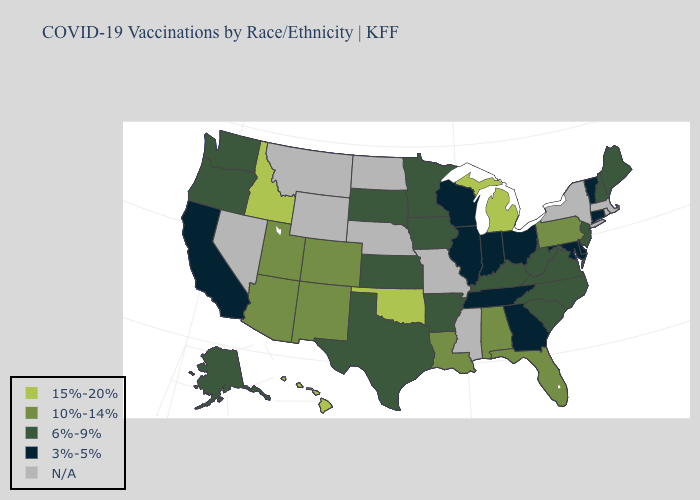What is the value of West Virginia?
Quick response, please. 6%-9%. What is the highest value in the MidWest ?
Be succinct. 15%-20%. Does Oklahoma have the highest value in the South?
Answer briefly. Yes. Among the states that border Maryland , which have the highest value?
Keep it brief. Pennsylvania. What is the value of Alaska?
Answer briefly. 6%-9%. What is the highest value in the USA?
Concise answer only. 15%-20%. What is the value of Kansas?
Be succinct. 6%-9%. Name the states that have a value in the range 15%-20%?
Quick response, please. Hawaii, Idaho, Michigan, Oklahoma. Does California have the lowest value in the West?
Answer briefly. Yes. Does the map have missing data?
Write a very short answer. Yes. Which states have the lowest value in the USA?
Write a very short answer. California, Connecticut, Delaware, Georgia, Illinois, Indiana, Maryland, Ohio, Tennessee, Vermont, Wisconsin. Name the states that have a value in the range N/A?
Write a very short answer. Massachusetts, Mississippi, Missouri, Montana, Nebraska, Nevada, New York, North Dakota, Rhode Island, Wyoming. What is the value of New Mexico?
Keep it brief. 10%-14%. Does Kansas have the lowest value in the USA?
Short answer required. No. 